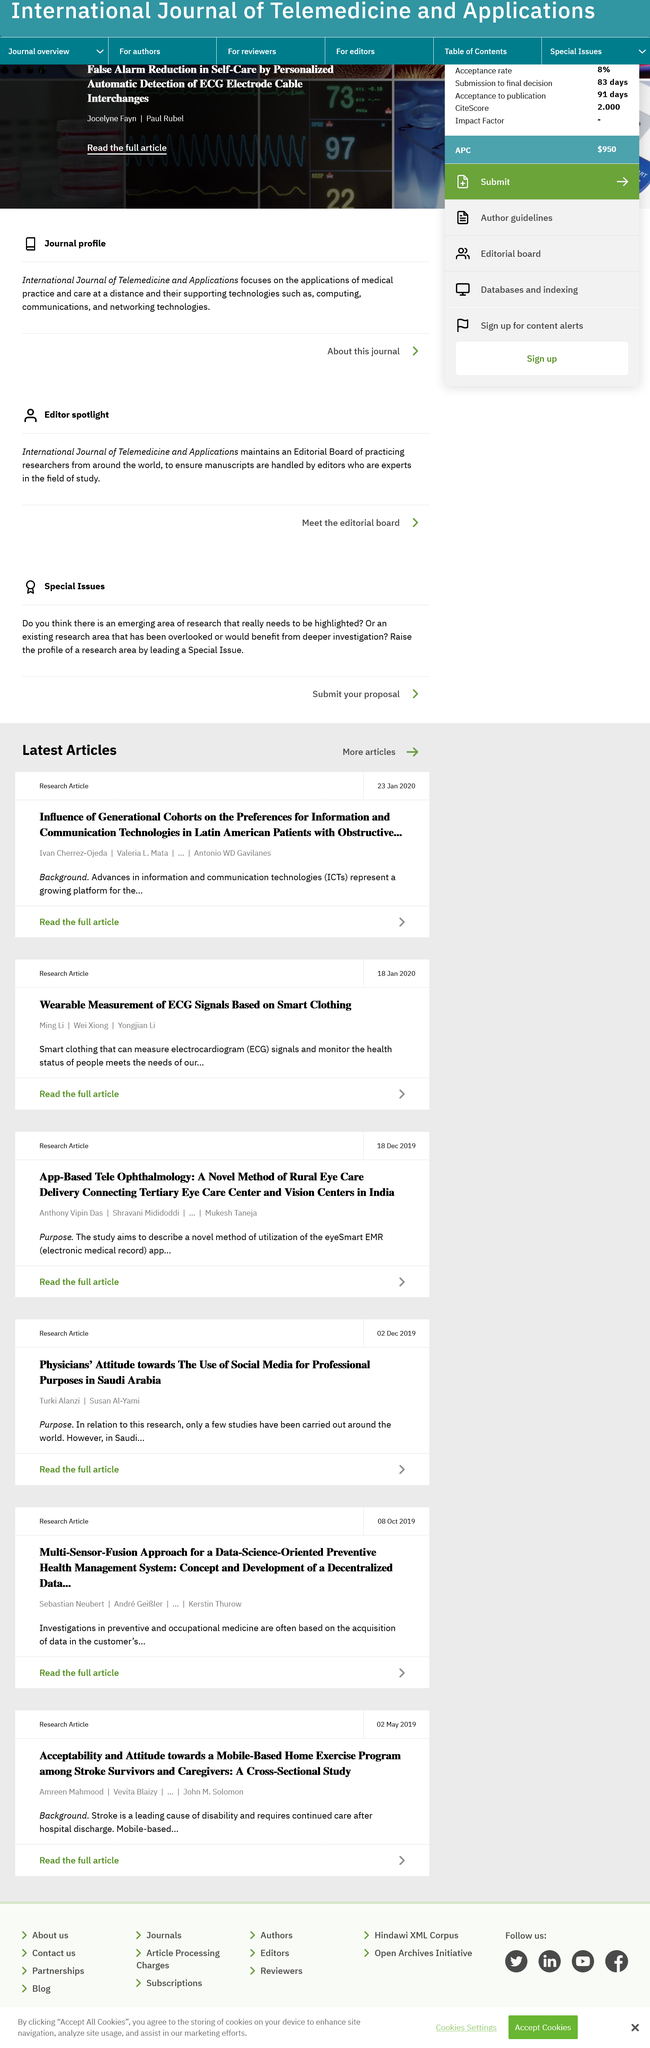Point out several critical features in this image. Electrocardiogram, commonly abbreviated as ECG, is a diagnostic test that measures the electrical activity of the heart. It is used to diagnose various heart conditions, such as heart rhythm disorders and heart muscle damage. During an ECG, small electrical signals are recorded through electrodes attached to the skin on various parts of the chest and limbs. The recorded signals are then analyzed to produce a graphical representation of the heart's electrical activity, which can be used to identify any abnormalities or irregularities. The authors of both articles are Ivan Cherrez-Ojeda, Valeria L.Mata, Antonio WD Gavilanes, Ming Li, Wei Xiong, and Yongjian Li. On January 18, 2020, a research article was written. 